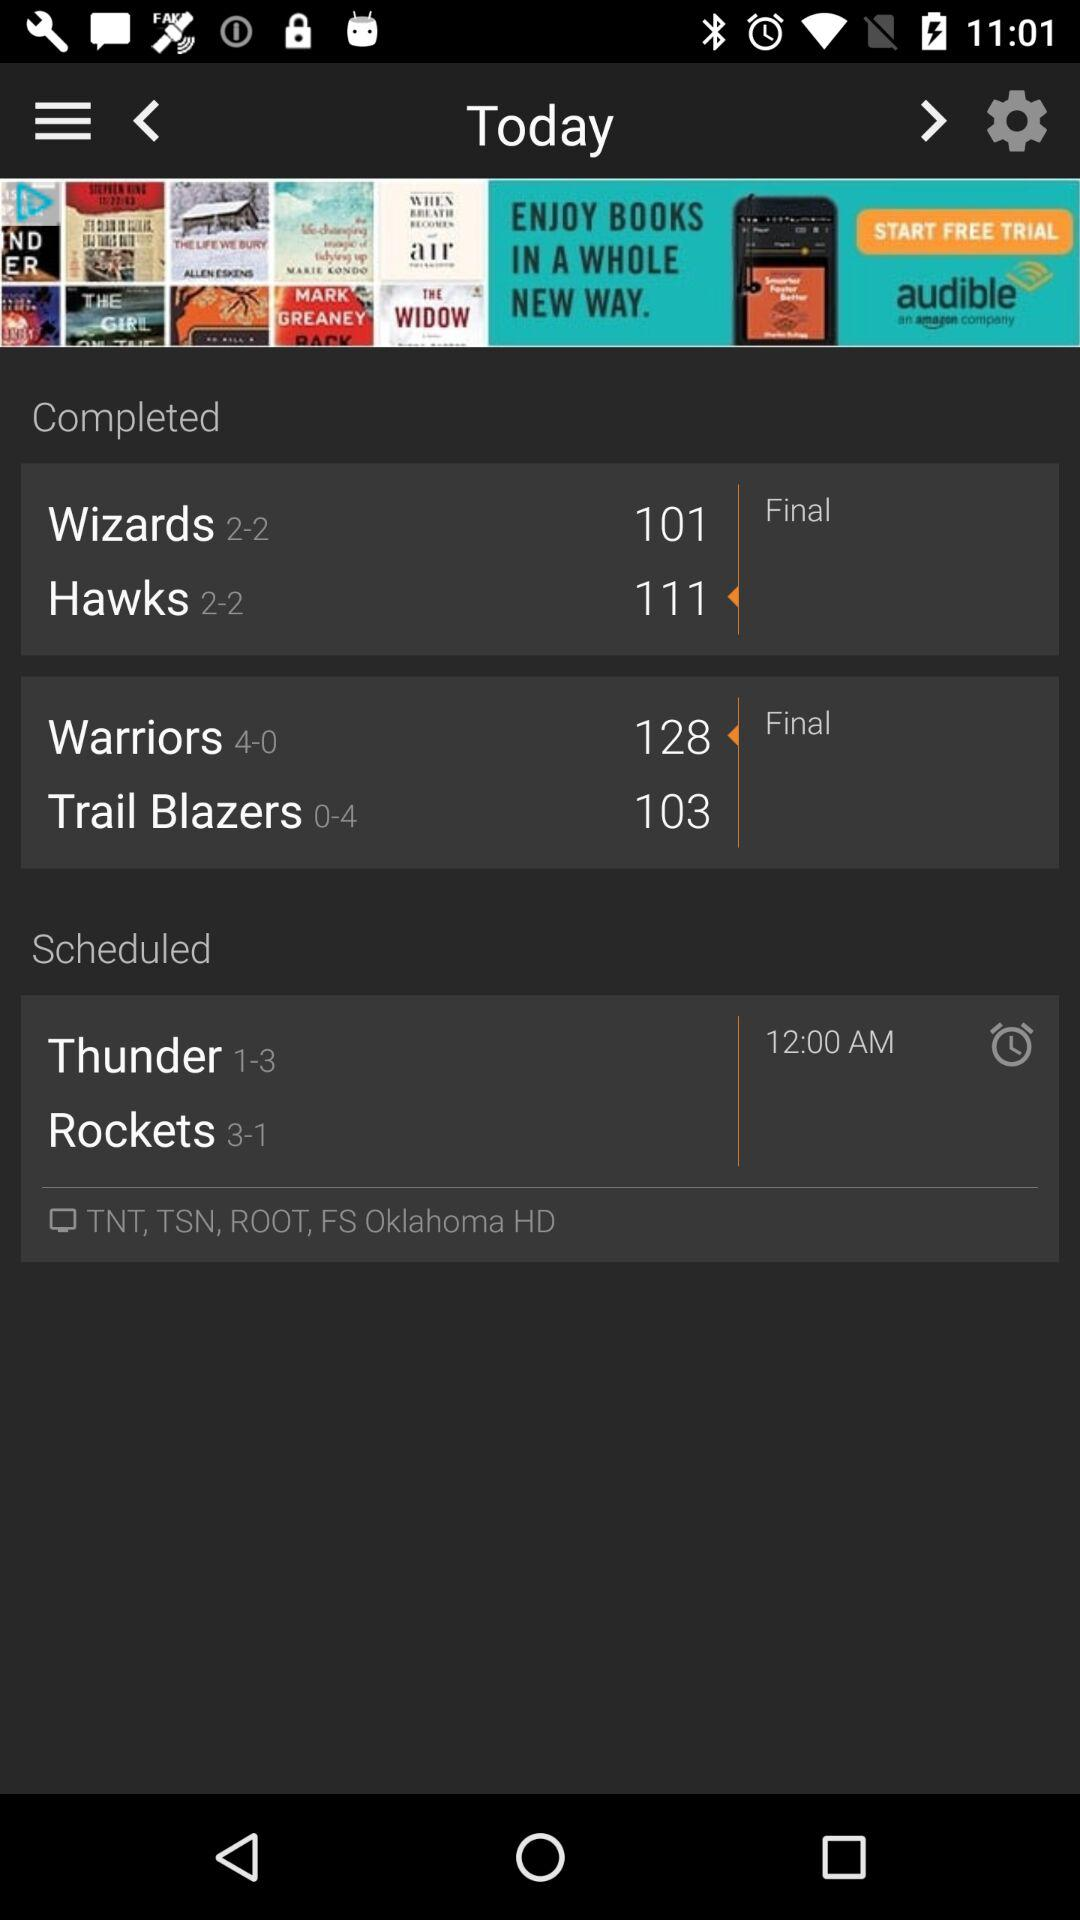What is the time scheduled for "Thunder"? The time scheduled for "Thunder" is 12:00 AM. 